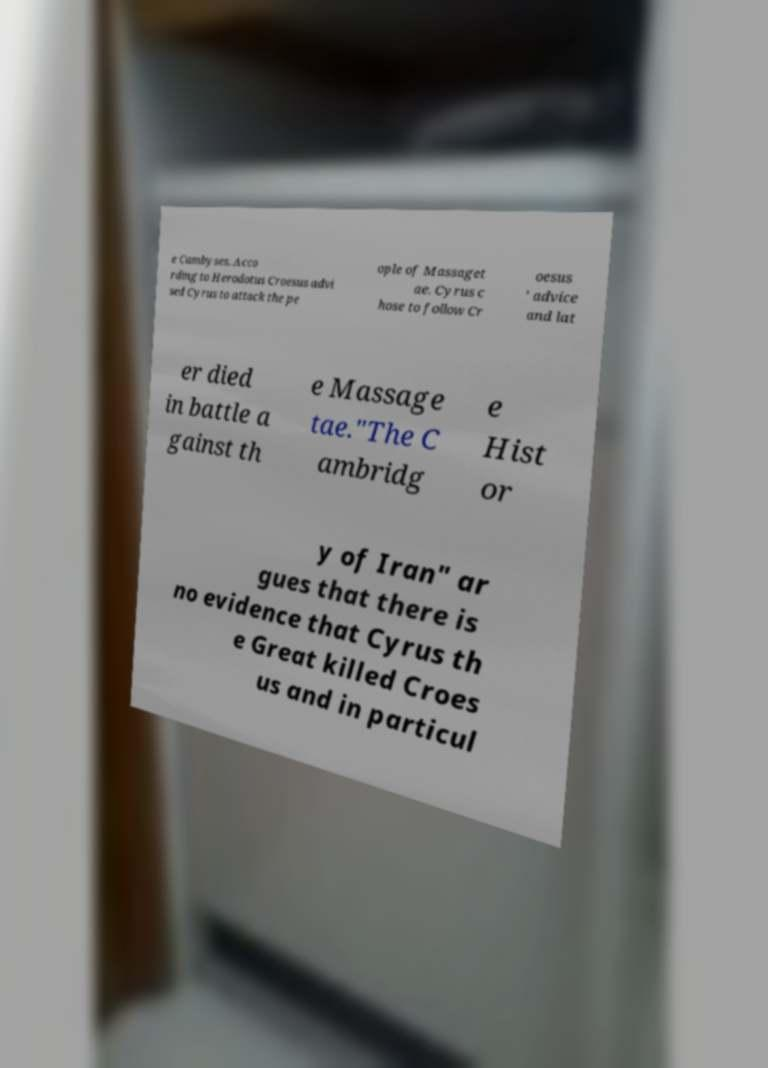Please identify and transcribe the text found in this image. e Cambyses. Acco rding to Herodotus Croesus advi sed Cyrus to attack the pe ople of Massaget ae. Cyrus c hose to follow Cr oesus ' advice and lat er died in battle a gainst th e Massage tae."The C ambridg e Hist or y of Iran" ar gues that there is no evidence that Cyrus th e Great killed Croes us and in particul 